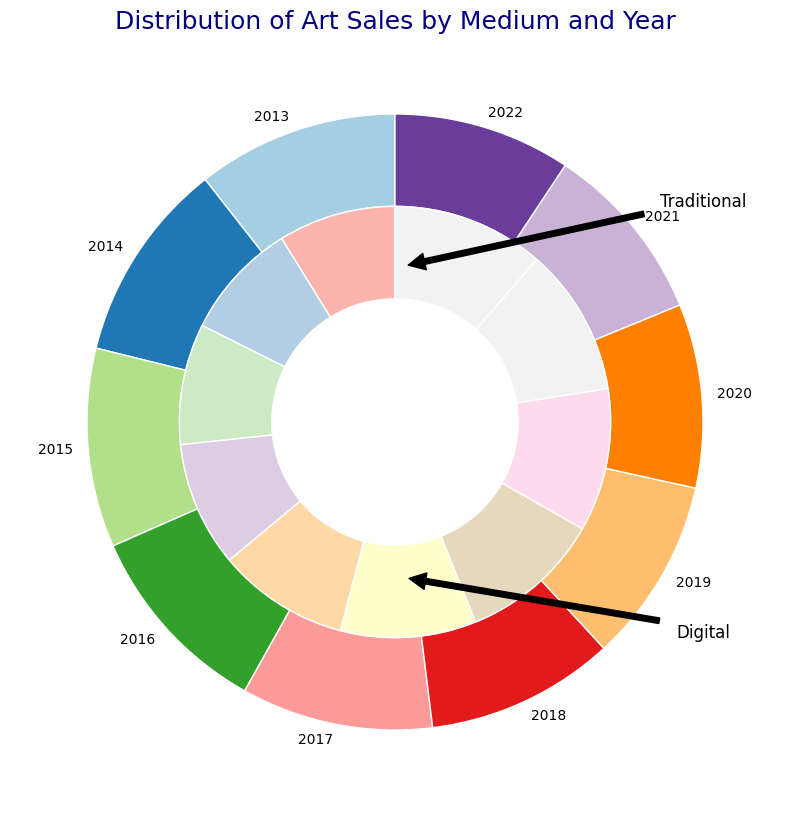What is the proportion of traditional art sales to the total sales in 2020? To find the proportion, refer to the ring chart segment for 2020 and look at the traditional sales part. The traditional art segment takes a more significant portion of the overall circle compared to the digital art in the same year, indicating a higher proportion.
Answer: Larger Which year had the closest proportion in art sales between traditional and digital mediums? Check each year's ring chart and compare how evenly the segments are split between traditional and digital art. For 2022, the segments for traditional and digital sales are the closest.
Answer: 2022 What is the trend of traditional art sales over the years? Observe the outer ring segments over the years. The segments for traditional art sales gradually increase in size from 2013 to 2022.
Answer: Increasing Which portion is larger in 2019, traditional or digital art sales? Compare the two segments (traditional vs. digital) for the year 2019. The traditional art sales segment is larger.
Answer: Traditional How did the digital art sales proportion change from 2013 to 2022? Compare the digital segments in the inner ring from 2013 to 2022. The digital segment increases in size, representing a growing proportion over time.
Answer: Increased What was the proportion difference between traditional and digital art sales in 2014? Look at the ring chart for 2014 and note the difference between the sizes of the segments for traditional and digital sales. The traditional segment is notably larger.
Answer: Traditional larger In which year did traditional art see the highest sales proportion? Check which year has the largest segment for traditional art in the ring chart. 2022 shows the largest proportion of traditional art sales.
Answer: 2022 What visual method does the ring chart use to differentiate between traditional and digital art sales? Observe the ring chart. The outer ring represents traditional sales while the inner ring represents digital sales, with different shades/colors aiding visual differentiation.
Answer: Outer and Inner Rings Which year had the smallest proportion of digital art sales relative to traditional art sales? Look for the year where the inner ring segment for digital art is smallest compared to the outer ring segment for traditional art. This occurs in 2013.
Answer: 2013 